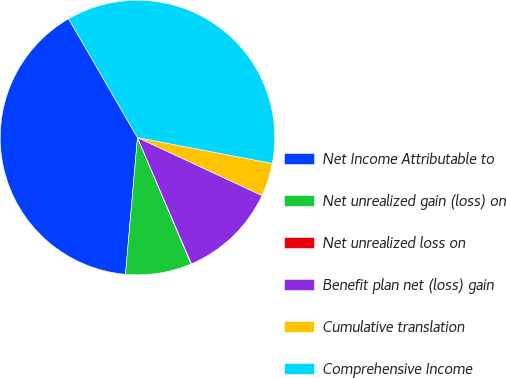<chart> <loc_0><loc_0><loc_500><loc_500><pie_chart><fcel>Net Income Attributable to<fcel>Net unrealized gain (loss) on<fcel>Net unrealized loss on<fcel>Benefit plan net (loss) gain<fcel>Cumulative translation<fcel>Comprehensive Income<nl><fcel>40.24%<fcel>7.77%<fcel>0.06%<fcel>11.63%<fcel>3.92%<fcel>36.38%<nl></chart> 